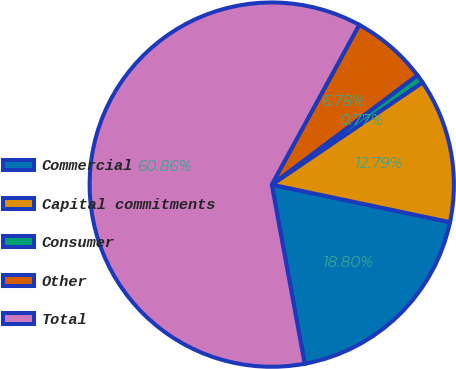<chart> <loc_0><loc_0><loc_500><loc_500><pie_chart><fcel>Commercial<fcel>Capital commitments<fcel>Consumer<fcel>Other<fcel>Total<nl><fcel>18.8%<fcel>12.79%<fcel>0.77%<fcel>6.78%<fcel>60.87%<nl></chart> 